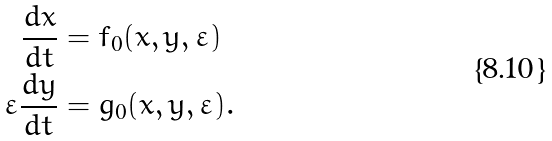Convert formula to latex. <formula><loc_0><loc_0><loc_500><loc_500>\frac { d x } { d t } & = f _ { 0 } ( x , y , \varepsilon ) \\ \varepsilon \frac { d y } { d t } & = g _ { 0 } ( x , y , \varepsilon ) .</formula> 